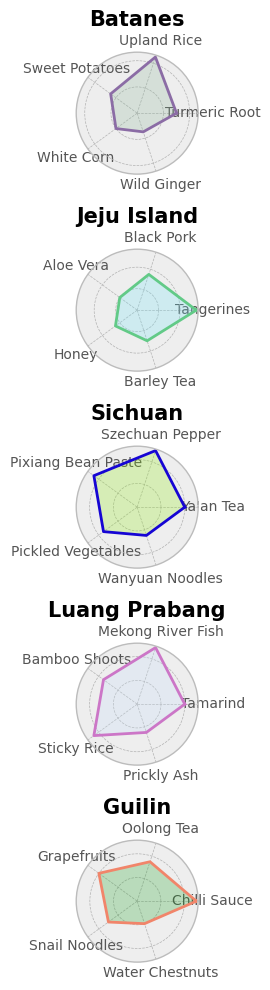What is the most common ingredient in Jeju Island? By examining the plot for Jeju Island, the length of the sectors represents the quantity of each ingredient. The longest sector corresponds to Tangerines, which indicates it is the most common ingredient.
Answer: Tangerines Which region has the widest variety of ingredients in the chart? To determine the region with the widest variety, count the number of unique ingredients shown for each region. The number of segments (each representing a different ingredient) for Luang Prabang, Guilin, Batanes, Sichuan, and Jeju Island is all the same.
Answer: All regions have equal variety Which region has the ingredient with the lowest quantity, and what is it? Look for the shortest sector in all regional plots. The shortest sector across all regions is for Wild Ginger in Batanes.
Answer: Batanes, Wild Ginger Compare the quantities of Aloe Vera in Jeju Island with White Corn in Batanes. Which one is higher and by how much? Identify the sector lengths for Aloe Vera in Jeju Island and White Corn in Batanes. Aloe Vera has a quantity of 20, and White Corn has 20 as well. No difference as both are equal.
Answer: They are equal What is the combined quantity of Szechuan Pepper and Ya'an Tea in Sichuan? Sum the quantities of Szechuan Pepper (50) and Ya'an Tea (40) in the plot for Sichuan. 50 + 40 = 90.
Answer: 90 Which region has the highest total quantity of ingredients, and what is the total? Sum the quantities of all ingredients in each region and compare the totals. By summing all values: Batanes (135), Jeju Island (165), Sichuan (195), Luang Prabang (195), Guilin (175). Sichuan and Luang Prabang have the highest total quantities of 195 each.
Answer: Sichuan and Luang Prabang, 195 How does the quantity of Black Pork in Jeju Island compare to Snail Noodles in Guilin? Review their sectors. Black Pork in Jeju Island is 35, and Snail Noodles in Guilin is 30. Black Pork in Jeju Island is higher by 5.
Answer: Black Pork is higher by 5 What's the average quantity of ingredients in Guilin? Calculate the average by summing the quantities of all ingredients in Guilin and dividing by the number of ingredients. (50 + 35 + 40 + 30 + 20) = 175 / 5 = 35.
Answer: 35 Which ingredient has the highest quantity across all regions? Look for the longest sector among all regions. Tangerines in Jeju Island have the highest quantity of 55.
Answer: Tangerines Compare the quantities of Mekong River Fish and Szechuan Pepper; which is larger and by what quantity? Examine the respective quantities in the plots. Mekong River Fish has a quantity of 50, and Szechuan Pepper also has 50. Hence, they are equal.
Answer: They are equal 